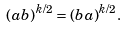Convert formula to latex. <formula><loc_0><loc_0><loc_500><loc_500>( a b ) ^ { k / 2 } = ( b a ) ^ { k / 2 } .</formula> 